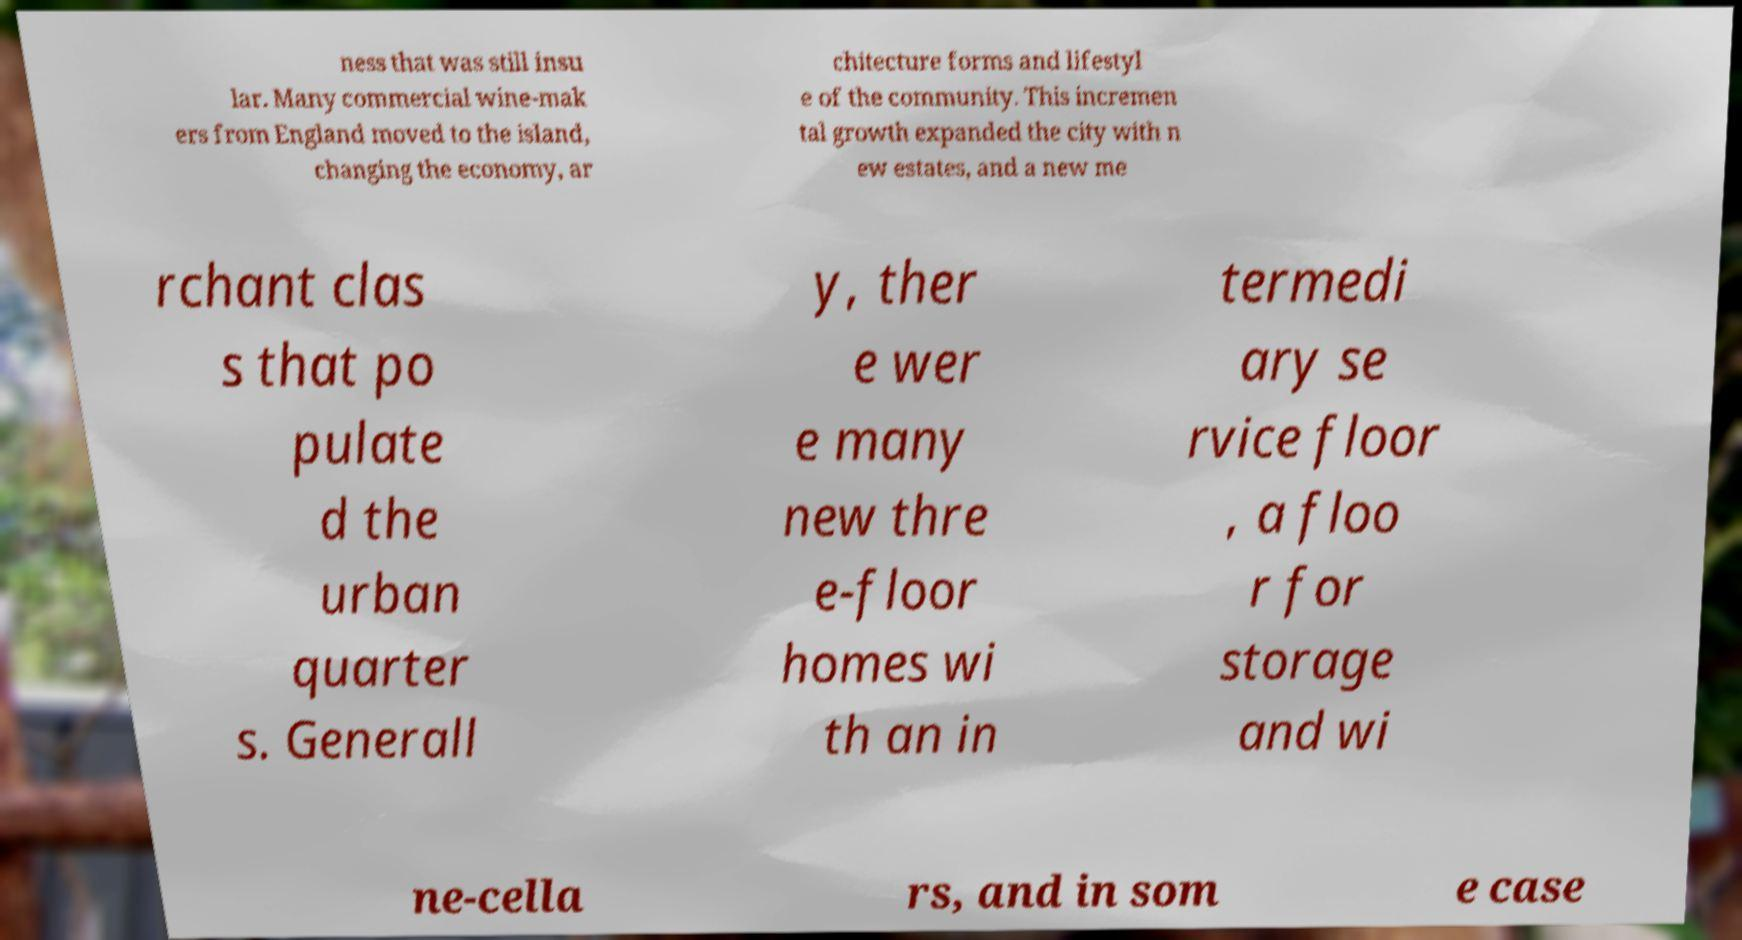For documentation purposes, I need the text within this image transcribed. Could you provide that? ness that was still insu lar. Many commercial wine-mak ers from England moved to the island, changing the economy, ar chitecture forms and lifestyl e of the community. This incremen tal growth expanded the city with n ew estates, and a new me rchant clas s that po pulate d the urban quarter s. Generall y, ther e wer e many new thre e-floor homes wi th an in termedi ary se rvice floor , a floo r for storage and wi ne-cella rs, and in som e case 